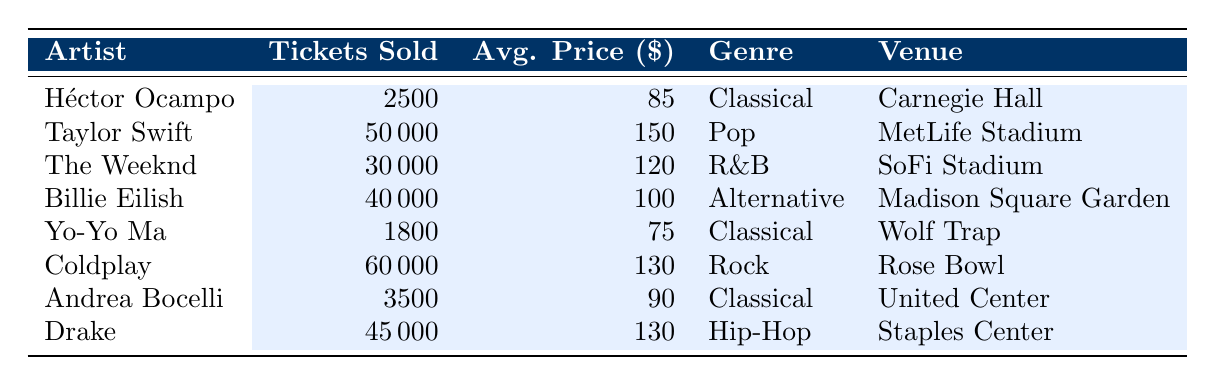What is the total number of tickets sold by Héctor Ocampo? Héctor Ocampo's ticket sales are listed in the table, showing that 2500 tickets were sold.
Answer: 2500 Which artist sold the most tickets in 2023? By reviewing the table, Coldplay sold the most tickets with a total of 60000 tickets.
Answer: Coldplay What is the average price of tickets sold by Billie Eilish? The table indicates that Billie Eilish's average ticket price is 100 dollars.
Answer: 100 How many more tickets did Taylor Swift sell than Yo-Yo Ma? Taylor Swift sold 50000 tickets while Yo-Yo Ma sold 1800 tickets. The difference is calculated as 50000 - 1800 = 48200.
Answer: 48200 Is it true that every artist who performs Classical music sold more than 2000 tickets? Héctor Ocampo sold 2500 tickets, Yo-Yo Ma sold 1800 tickets (which is less than 2000), and Andrea Bocelli sold 3500 tickets. Since Yo-Yo Ma did not sell more than 2000 tickets, the statement is false.
Answer: No Which genre had the highest average ticket price, and what was that price? Analyzing the data, the average prices for genres are: Classical (85), Pop (150), R&B (120), Alternative (100), Rock (130), and Hip-Hop (130). The highest average price is for Pop at 150 dollars.
Answer: Pop, 150 If you combine the tickets sold by Andrea Bocelli and Héctor Ocampo, how many tickets were sold? Summing their ticket sales, Andrea Bocelli sold 3500 tickets and Héctor Ocampo sold 2500 tickets, so total tickets sold is 3500 + 2500 = 6000.
Answer: 6000 What percentage of tickets sold by The Weeknd were sold at an average price above 100 dollars? The Weeknd sold 30000 tickets at an average price of 120 dollars, which is above 100 dollars. Therefore, the percentage is (30000 / 30000) * 100 = 100%.
Answer: 100% What venues hosted the Classical music artists? The venues listed for Classical artists are Carnegie Hall (Héctor Ocampo), Wolf Trap (Yo-Yo Ma), and United Center (Andrea Bocelli).
Answer: Carnegie Hall, Wolf Trap, United Center 